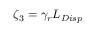<formula> <loc_0><loc_0><loc_500><loc_500>\zeta _ { 3 } = \gamma _ { r } L _ { D i s p }</formula> 